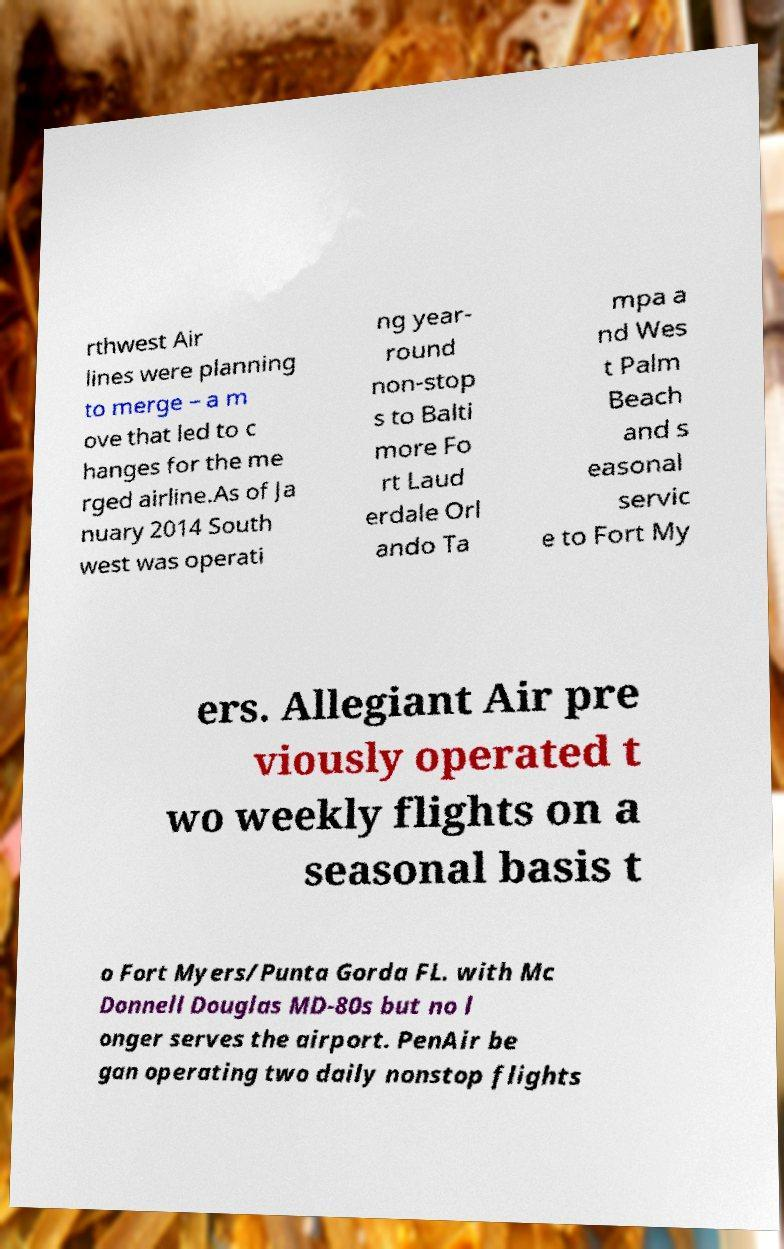For documentation purposes, I need the text within this image transcribed. Could you provide that? rthwest Air lines were planning to merge – a m ove that led to c hanges for the me rged airline.As of Ja nuary 2014 South west was operati ng year- round non-stop s to Balti more Fo rt Laud erdale Orl ando Ta mpa a nd Wes t Palm Beach and s easonal servic e to Fort My ers. Allegiant Air pre viously operated t wo weekly flights on a seasonal basis t o Fort Myers/Punta Gorda FL. with Mc Donnell Douglas MD-80s but no l onger serves the airport. PenAir be gan operating two daily nonstop flights 